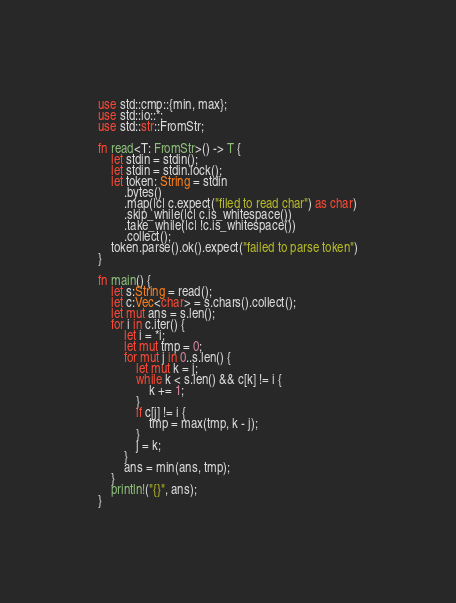Convert code to text. <code><loc_0><loc_0><loc_500><loc_500><_Rust_>use std::cmp::{min, max};
use std::io::*;
use std::str::FromStr;

fn read<T: FromStr>() -> T {
    let stdin = stdin();
    let stdin = stdin.lock();
    let token: String = stdin
        .bytes()
        .map(|c| c.expect("filed to read char") as char)
        .skip_while(|c| c.is_whitespace())
        .take_while(|c| !c.is_whitespace())
        .collect();
    token.parse().ok().expect("failed to parse token")
}

fn main() {
    let s:String = read();
    let c:Vec<char> = s.chars().collect();
    let mut ans = s.len();
    for i in c.iter() {
        let i = *i;
        let mut tmp = 0;
        for mut j in 0..s.len() {
            let mut k = j;
            while k < s.len() && c[k] != i {
                k += 1;
            }
            if c[j] != i {
                tmp = max(tmp, k - j);
            }
            j = k;
        }
        ans = min(ans, tmp);
    }
    println!("{}", ans);
}</code> 